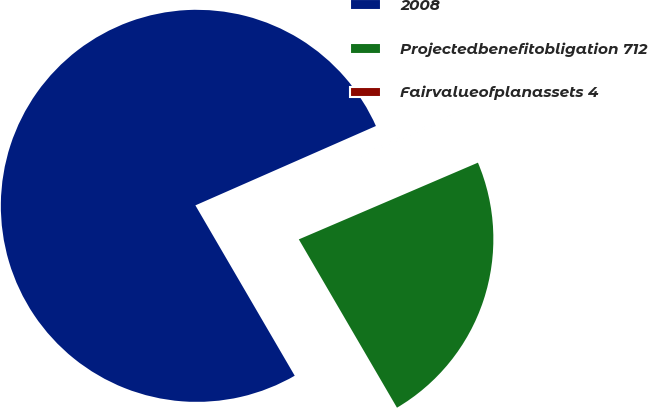<chart> <loc_0><loc_0><loc_500><loc_500><pie_chart><fcel>2008<fcel>Projectedbenefitobligation 712<fcel>Fairvalueofplanassets 4<nl><fcel>76.81%<fcel>23.04%<fcel>0.15%<nl></chart> 